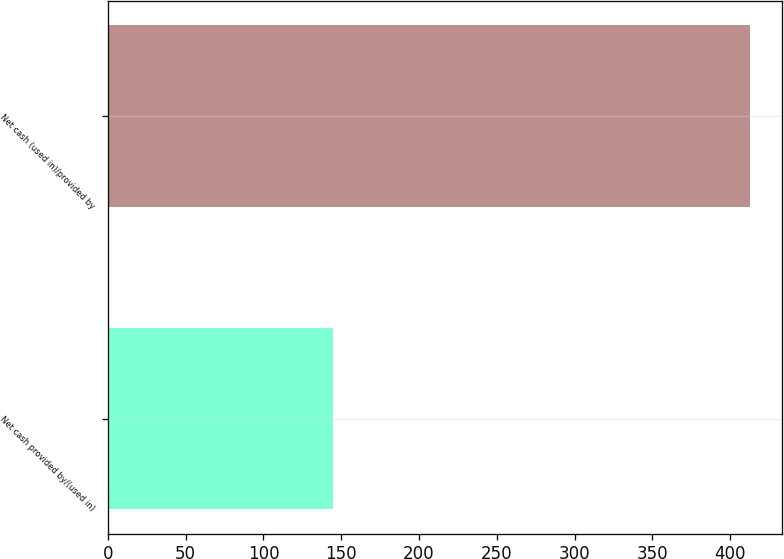Convert chart. <chart><loc_0><loc_0><loc_500><loc_500><bar_chart><fcel>Net cash provided by/(used in)<fcel>Net cash (used in)/provided by<nl><fcel>144.5<fcel>412.8<nl></chart> 